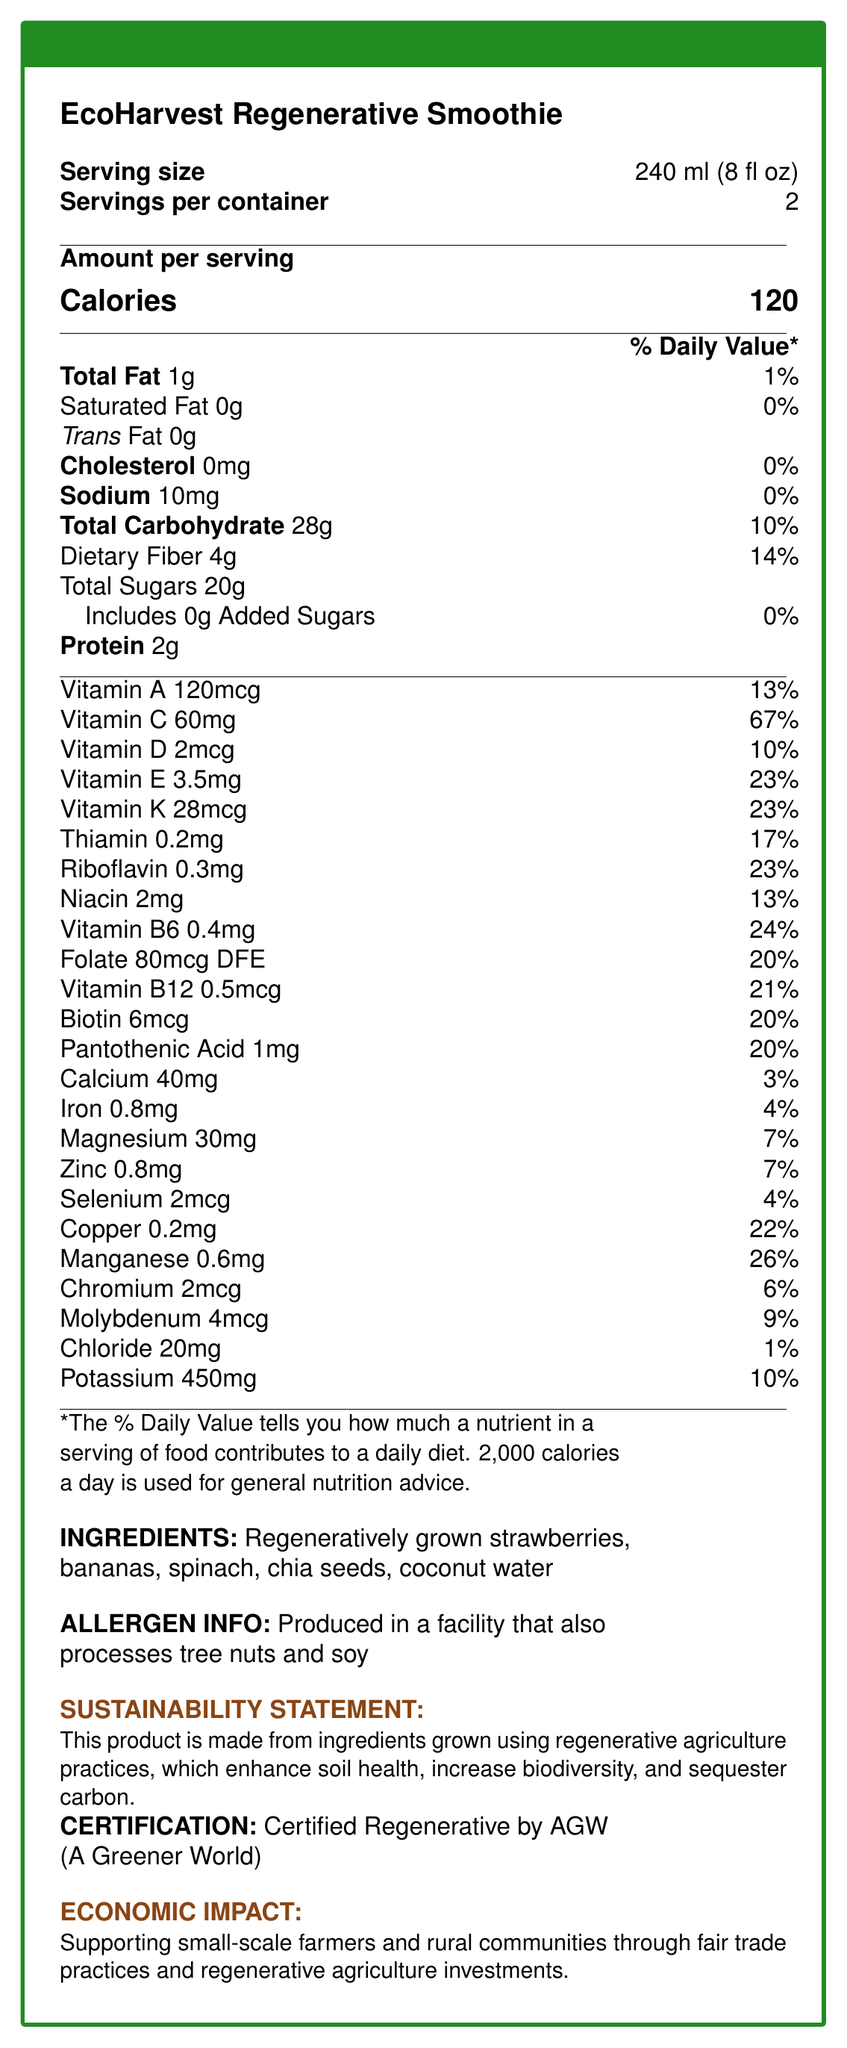what is the serving size of the EcoHarvest Regenerative Smoothie? The document specifies that the serving size of the smoothie is 240 ml (8 fl oz).
Answer: 240 ml (8 fl oz) how many calories are there per serving? The document lists the calories per serving as 120.
Answer: 120 what is the percentage daily value of Vitamin C per serving? The document indicates that the daily value percentage for Vitamin C per serving is 67%.
Answer: 67% identify two minerals listed in the nutrition facts and their daily value percentages. The document lists Magnesium as 7% and Zinc as 7% of the daily value per serving.
Answer: Magnesium 7%, Zinc 7% list three ingredients used in the EcoHarvest Regenerative Smoothie. The document lists several ingredients, among them are regeneratively grown strawberries, bananas, and spinach.
Answer: Regeneratively grown strawberries, Regeneratively grown bananas, Regeneratively grown spinach how much protein is in one serving? According to the document, there are 2 grams of protein per serving.
Answer: 2g how many servings are there in a container? A. 1 B. 2 C. 3 The document states that there are 2 servings per container.
Answer: B what is the amount of dietary fiber in one serving? A. 2g B. 4g C. 6g D. 8g The document specifies that there are 4 grams of dietary fiber per serving.
Answer: B does the product contain any added sugars? The document clearly states that there are 0 grams of added sugars.
Answer: No is the EcoHarvest Regenerative Smoothie certified by any organization? The document mentions that the product is Certified Regenerative by AGW (A Greener World).
Answer: Yes does the EcoHarvest Regenerative Smoothie support small-scale farmers? The document states that the product supports small-scale farmers and rural communities through fair trade practices and regenerative agriculture investments.
Answer: Yes can you determine the exact process used for growing the ingredients from the information given? The document states that the ingredients are grown using regenerative agriculture practices but does not detail the exact processes.
Answer: Not enough information summarize the main idea of the nutrition facts document for the EcoHarvest Regenerative Smoothie. The document is designed to offer a comprehensive overview of the nutritional content, ingredients, and broader impact of the EcoHarvest Regenerative Smoothie.
Answer: The document provides nutritional information for the EcoHarvest Regenerative Smoothie, a product that uses ingredients grown with regenerative agriculture practices. It lists the smoothie’s serving size, servings per container, calorie content, amounts of various nutrients, and daily values. Additionally, it includes information on the ingredients, allergen information, sustainability statement, certification, and economic impact. 